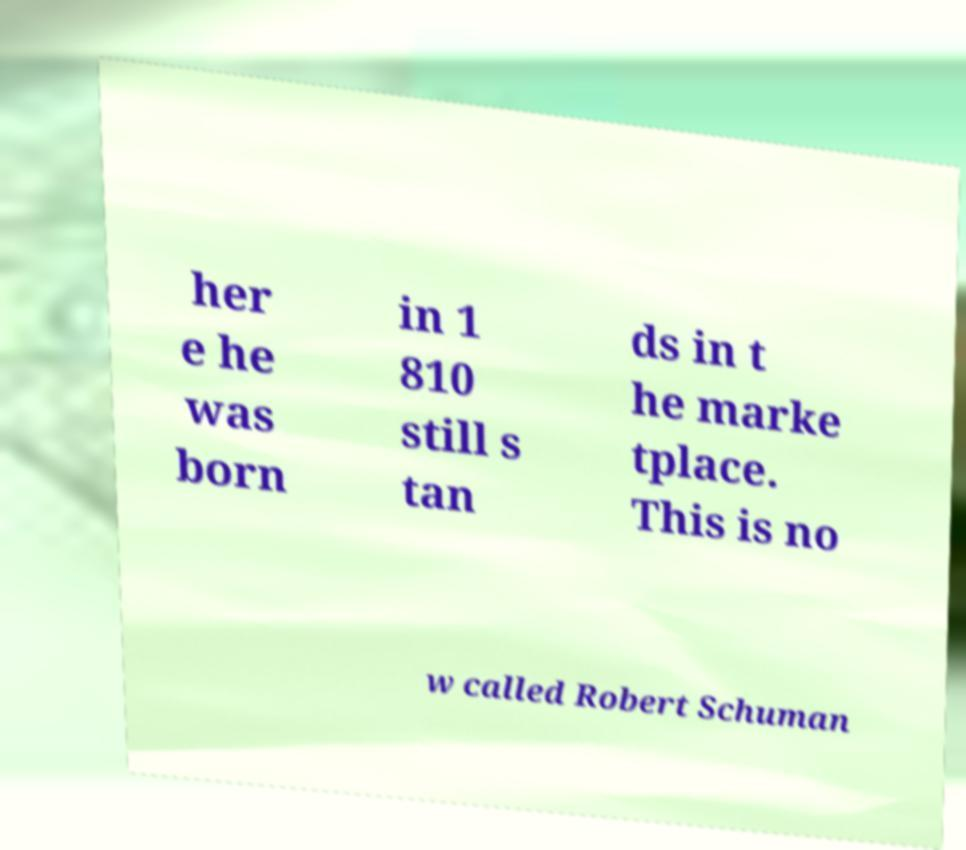Could you extract and type out the text from this image? her e he was born in 1 810 still s tan ds in t he marke tplace. This is no w called Robert Schuman 